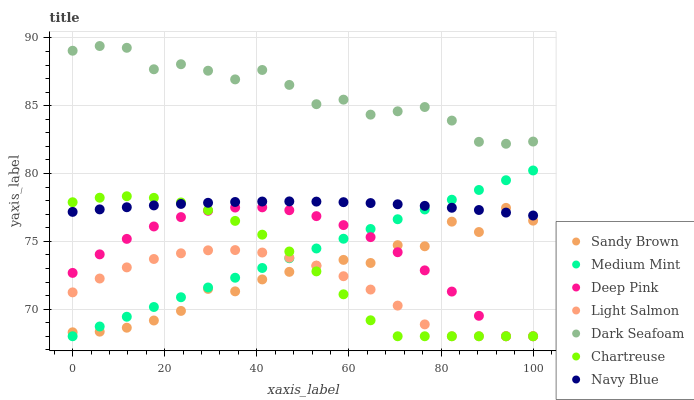Does Light Salmon have the minimum area under the curve?
Answer yes or no. Yes. Does Dark Seafoam have the maximum area under the curve?
Answer yes or no. Yes. Does Deep Pink have the minimum area under the curve?
Answer yes or no. No. Does Deep Pink have the maximum area under the curve?
Answer yes or no. No. Is Medium Mint the smoothest?
Answer yes or no. Yes. Is Sandy Brown the roughest?
Answer yes or no. Yes. Is Light Salmon the smoothest?
Answer yes or no. No. Is Light Salmon the roughest?
Answer yes or no. No. Does Medium Mint have the lowest value?
Answer yes or no. Yes. Does Navy Blue have the lowest value?
Answer yes or no. No. Does Dark Seafoam have the highest value?
Answer yes or no. Yes. Does Deep Pink have the highest value?
Answer yes or no. No. Is Light Salmon less than Navy Blue?
Answer yes or no. Yes. Is Dark Seafoam greater than Medium Mint?
Answer yes or no. Yes. Does Sandy Brown intersect Light Salmon?
Answer yes or no. Yes. Is Sandy Brown less than Light Salmon?
Answer yes or no. No. Is Sandy Brown greater than Light Salmon?
Answer yes or no. No. Does Light Salmon intersect Navy Blue?
Answer yes or no. No. 